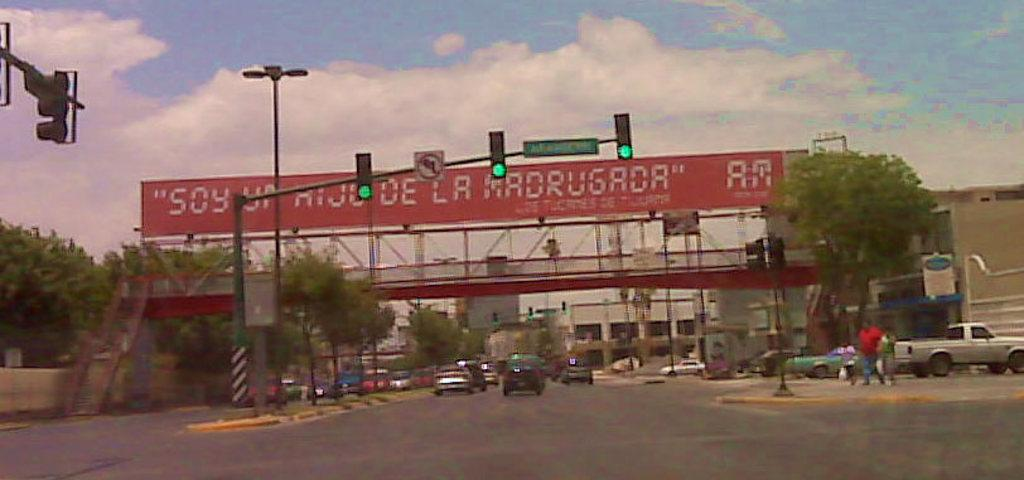What can be seen on the road in the image? There are vehicles on the road in the image. What helps regulate the flow of traffic in the image? There are traffic lights in the image. What is visible in the sky in the image? Clouds are visible in the sky in the image. What type of vegetation can be seen in the image? There are trees in the image. Where is the mom sitting on the bed in the image? There is no bed or mom present in the image. What is the thumb doing in the image? There is no thumb present in the image. 